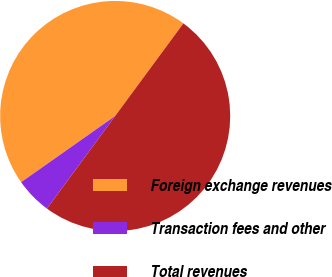Convert chart to OTSL. <chart><loc_0><loc_0><loc_500><loc_500><pie_chart><fcel>Foreign exchange revenues<fcel>Transaction fees and other<fcel>Total revenues<nl><fcel>44.87%<fcel>5.13%<fcel>50.0%<nl></chart> 